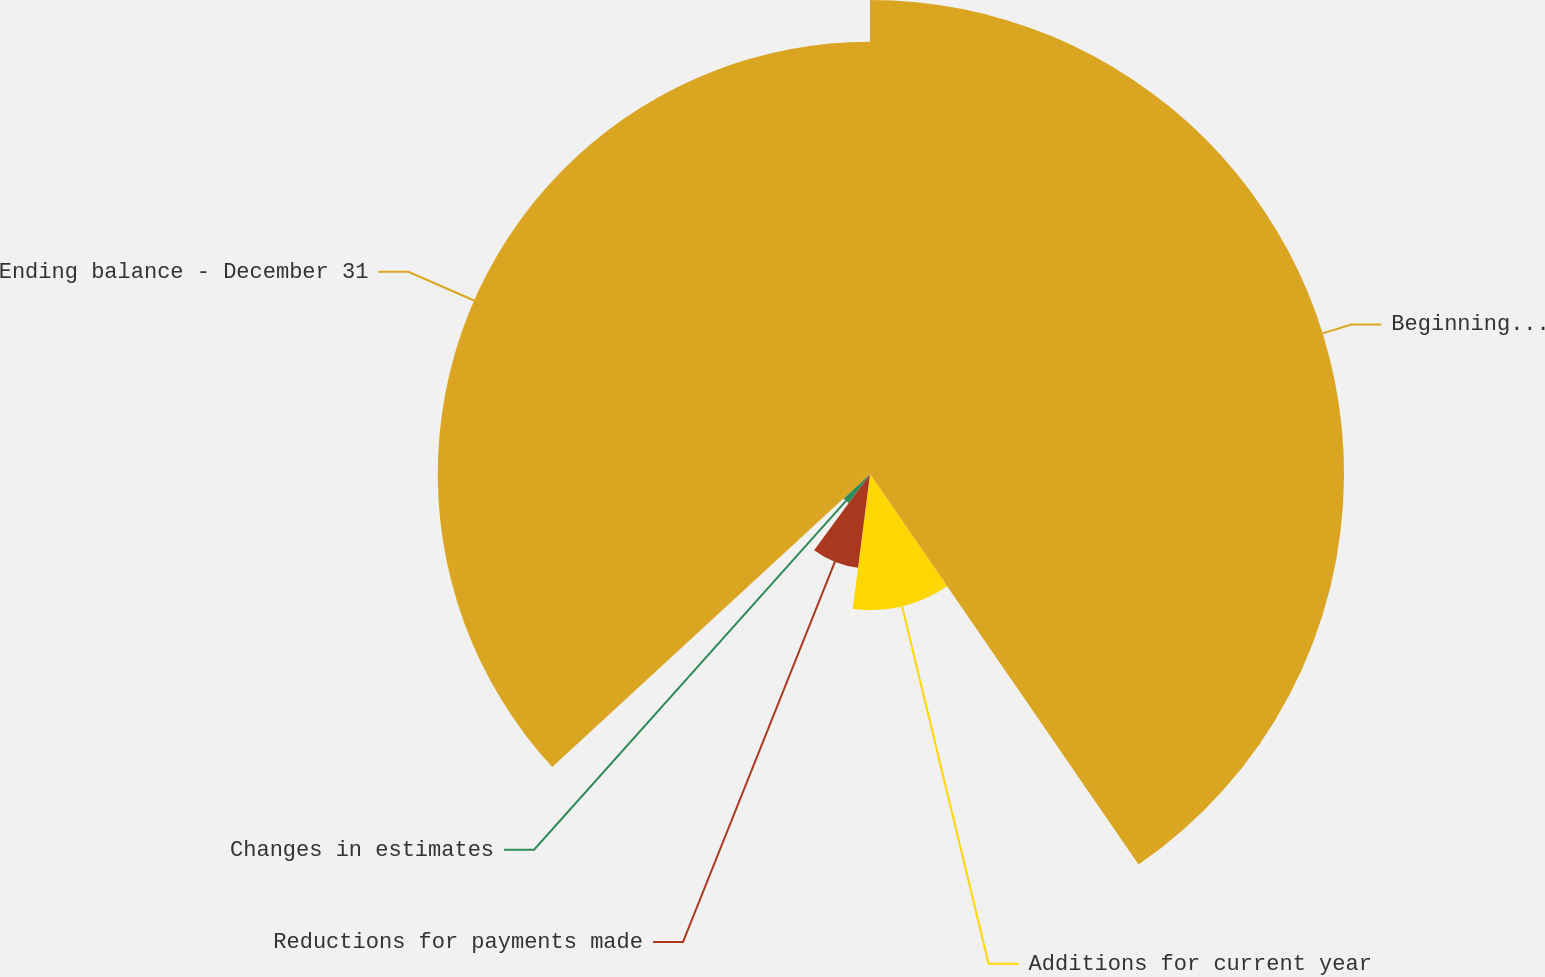Convert chart. <chart><loc_0><loc_0><loc_500><loc_500><pie_chart><fcel>Beginning balance - January 1<fcel>Additions for current year<fcel>Reductions for payments made<fcel>Changes in estimates<fcel>Ending balance - December 31<nl><fcel>40.41%<fcel>11.61%<fcel>8.05%<fcel>3.07%<fcel>36.85%<nl></chart> 